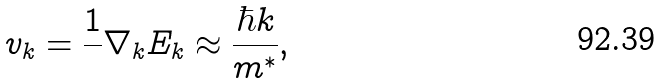Convert formula to latex. <formula><loc_0><loc_0><loc_500><loc_500>v _ { k } = \frac { 1 } { } \nabla _ { k } E _ { k } \approx \frac { \hbar { k } } { m ^ { * } } ,</formula> 